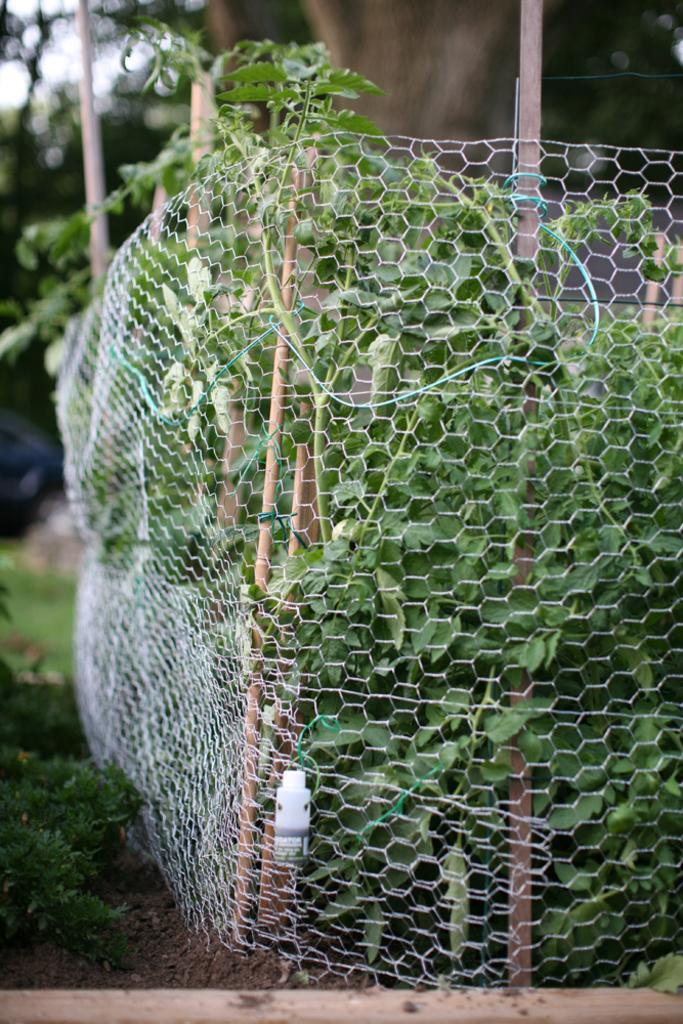How would you summarize this image in a sentence or two? In this image I can see a railing, background I can see trees in green color and the sky is in white color. 